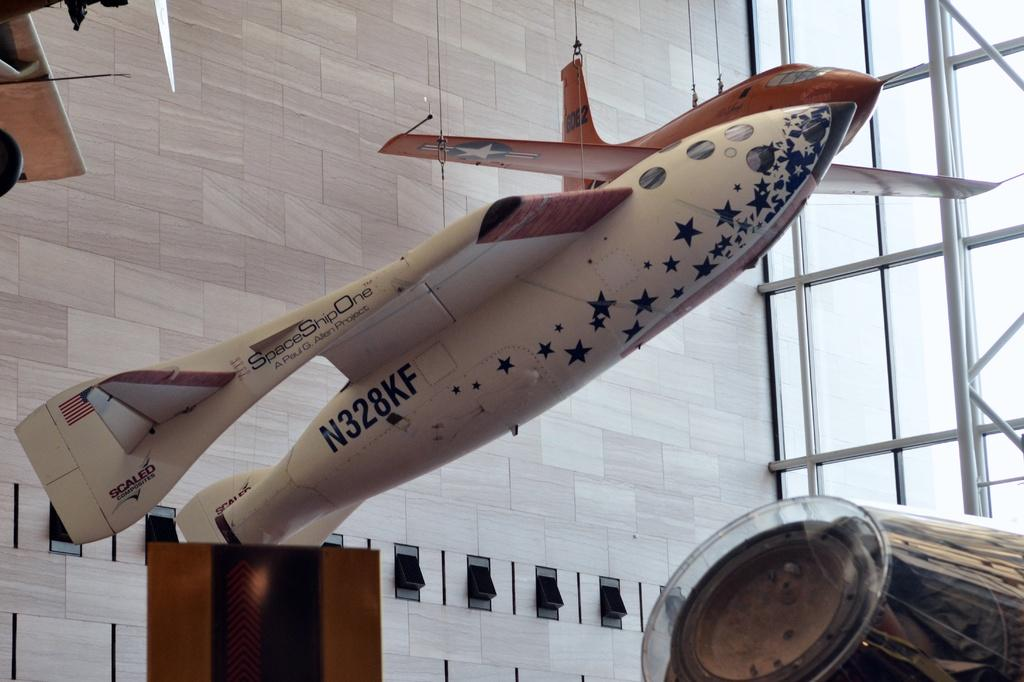What is the main subject of the image? The main subject of the image is an aircraft. Can you describe the color of the aircraft? The aircraft is in brown and white color. What type of windows are on the aircraft? There are glass windows on the aircraft. What color is the wall in the image? The wall is in cream color. What type of art is displayed on the wall in the image? There is no art displayed on the wall in the image; it is simply a cream-colored wall. How does the aircraft cause destruction in the image? The image does not depict any destruction caused by the aircraft; it is a static image of an aircraft with glass windows and a cream-colored wall. 